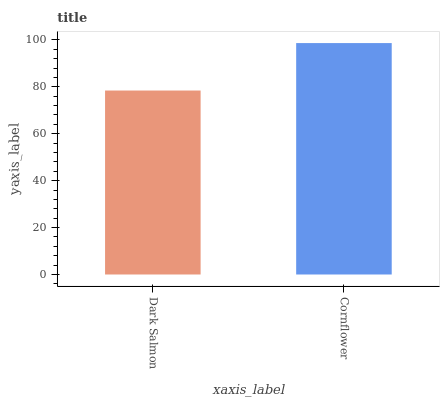Is Cornflower the minimum?
Answer yes or no. No. Is Cornflower greater than Dark Salmon?
Answer yes or no. Yes. Is Dark Salmon less than Cornflower?
Answer yes or no. Yes. Is Dark Salmon greater than Cornflower?
Answer yes or no. No. Is Cornflower less than Dark Salmon?
Answer yes or no. No. Is Cornflower the high median?
Answer yes or no. Yes. Is Dark Salmon the low median?
Answer yes or no. Yes. Is Dark Salmon the high median?
Answer yes or no. No. Is Cornflower the low median?
Answer yes or no. No. 